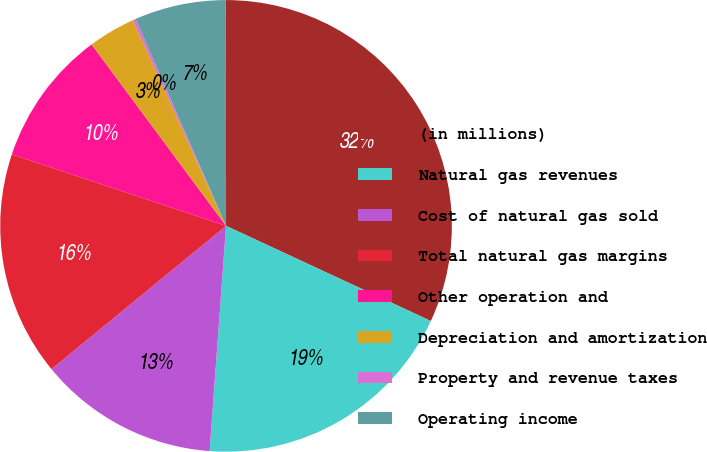<chart> <loc_0><loc_0><loc_500><loc_500><pie_chart><fcel>(in millions)<fcel>Natural gas revenues<fcel>Cost of natural gas sold<fcel>Total natural gas margins<fcel>Other operation and<fcel>Depreciation and amortization<fcel>Property and revenue taxes<fcel>Operating income<nl><fcel>31.93%<fcel>19.24%<fcel>12.9%<fcel>16.07%<fcel>9.72%<fcel>3.38%<fcel>0.21%<fcel>6.55%<nl></chart> 